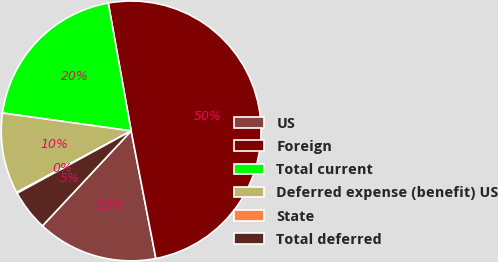Convert chart. <chart><loc_0><loc_0><loc_500><loc_500><pie_chart><fcel>US<fcel>Foreign<fcel>Total current<fcel>Deferred expense (benefit) US<fcel>State<fcel>Total deferred<nl><fcel>15.01%<fcel>49.77%<fcel>19.98%<fcel>10.05%<fcel>0.11%<fcel>5.08%<nl></chart> 